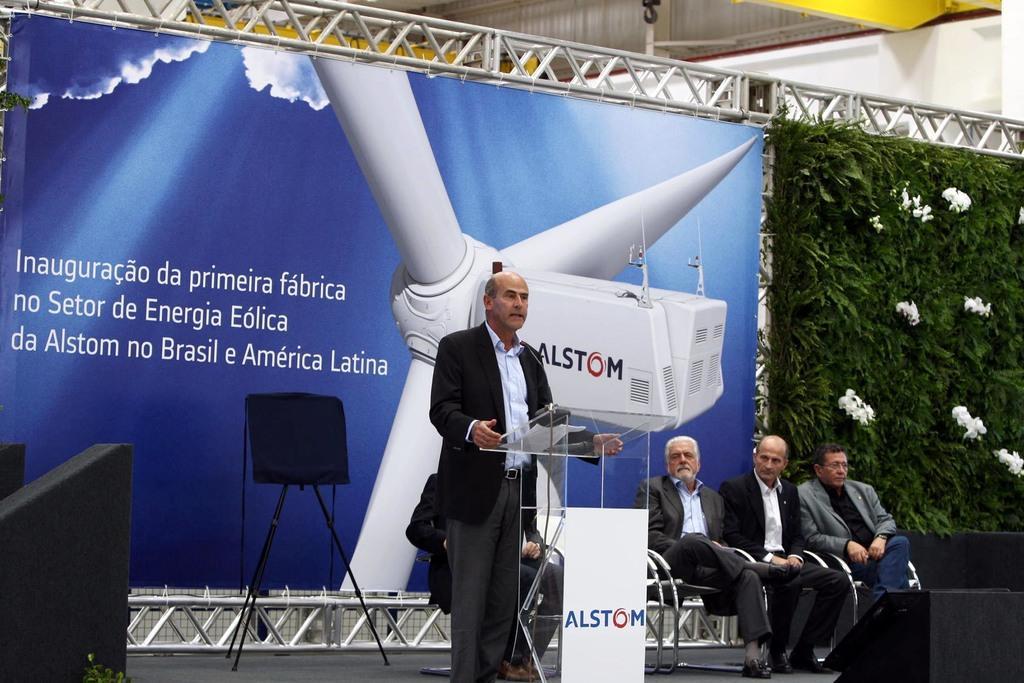Can you describe this image briefly? In this image there is a man standing near a podium, in the background there are people sitting on chairs and there in a stand on that there are few objects, behind the stand there is a banner on that banner there is text and a picture, beside the banner there are plants, on the bottom right and bottom left there are boxes, at the top there is an iron frame. 